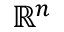<formula> <loc_0><loc_0><loc_500><loc_500>\mathbb { R } ^ { n }</formula> 